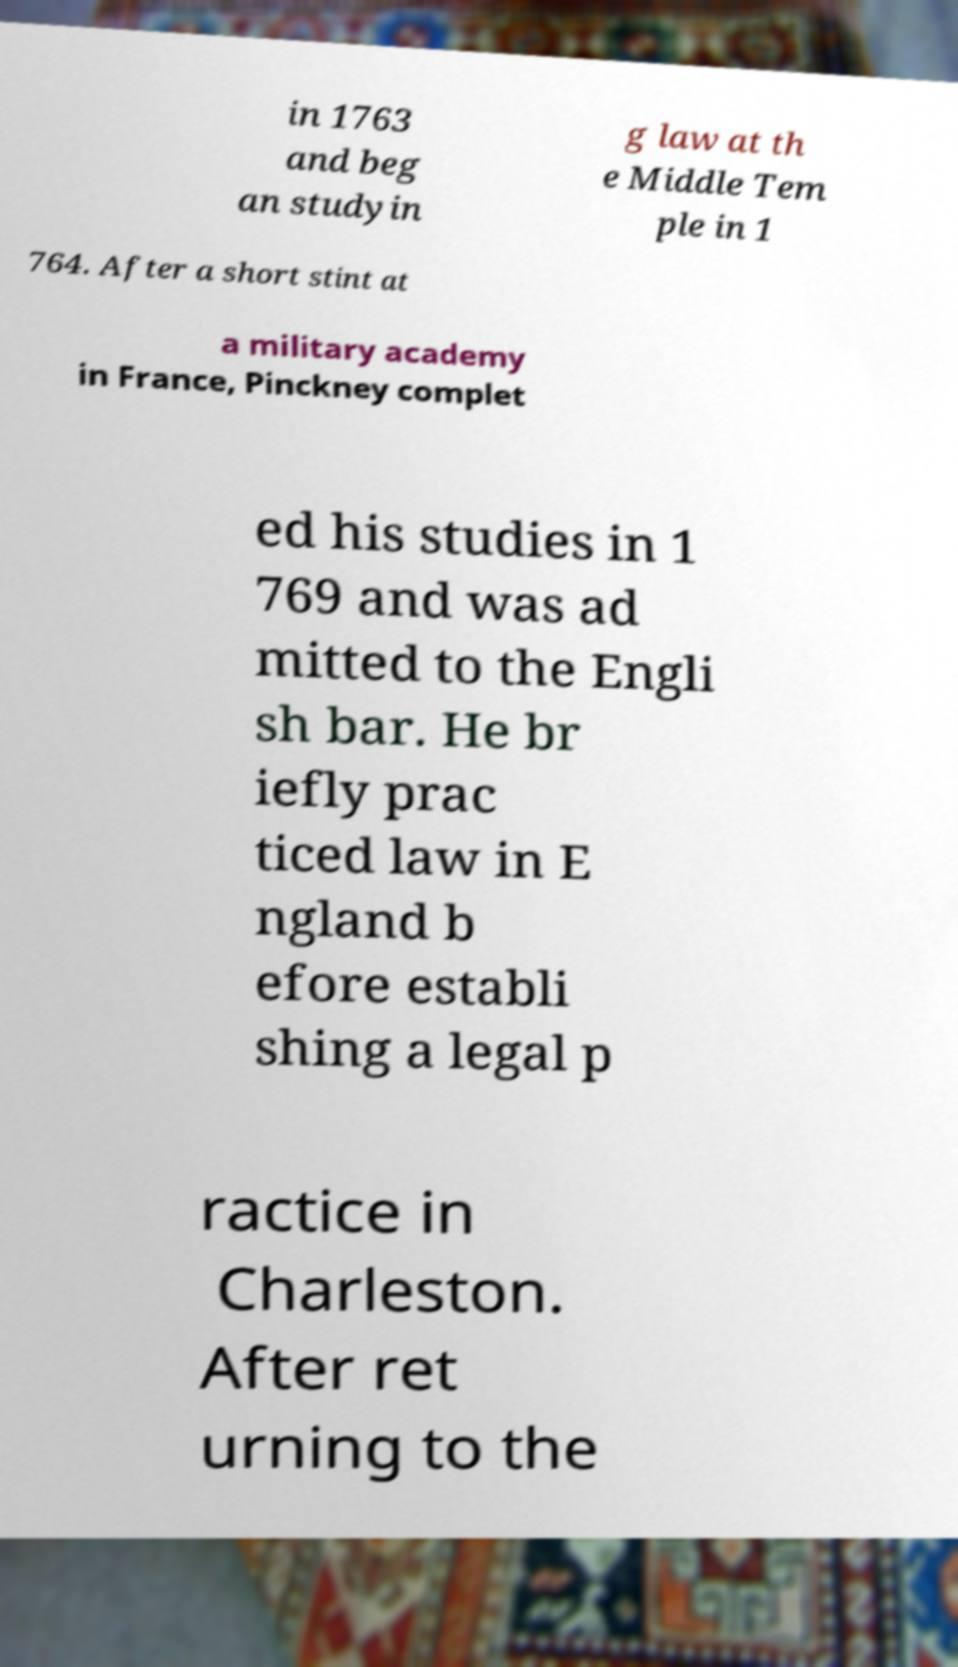Can you accurately transcribe the text from the provided image for me? in 1763 and beg an studyin g law at th e Middle Tem ple in 1 764. After a short stint at a military academy in France, Pinckney complet ed his studies in 1 769 and was ad mitted to the Engli sh bar. He br iefly prac ticed law in E ngland b efore establi shing a legal p ractice in Charleston. After ret urning to the 